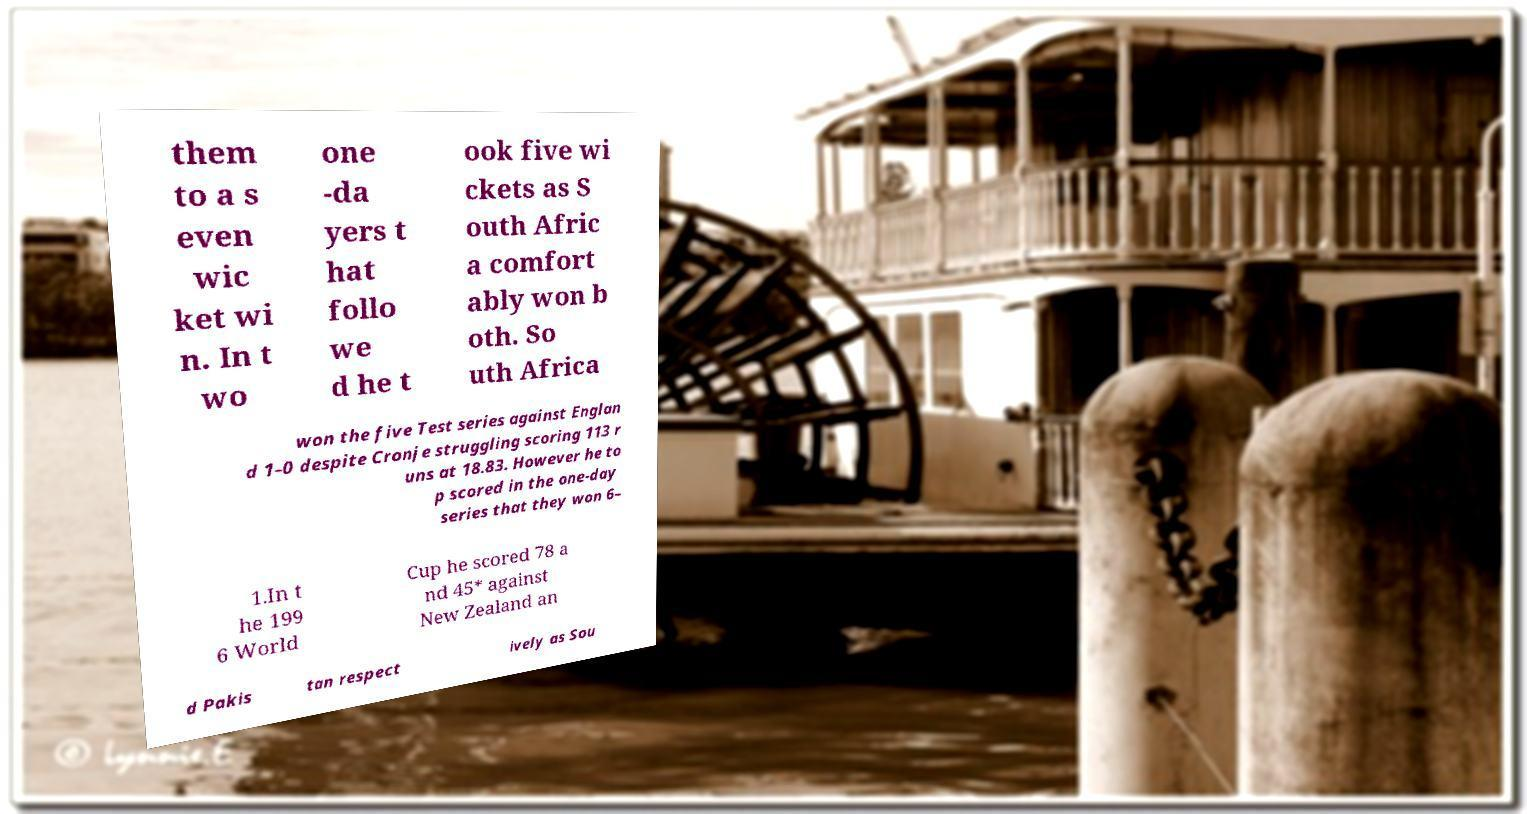For documentation purposes, I need the text within this image transcribed. Could you provide that? them to a s even wic ket wi n. In t wo one -da yers t hat follo we d he t ook five wi ckets as S outh Afric a comfort ably won b oth. So uth Africa won the five Test series against Englan d 1–0 despite Cronje struggling scoring 113 r uns at 18.83. However he to p scored in the one-day series that they won 6– 1.In t he 199 6 World Cup he scored 78 a nd 45* against New Zealand an d Pakis tan respect ively as Sou 